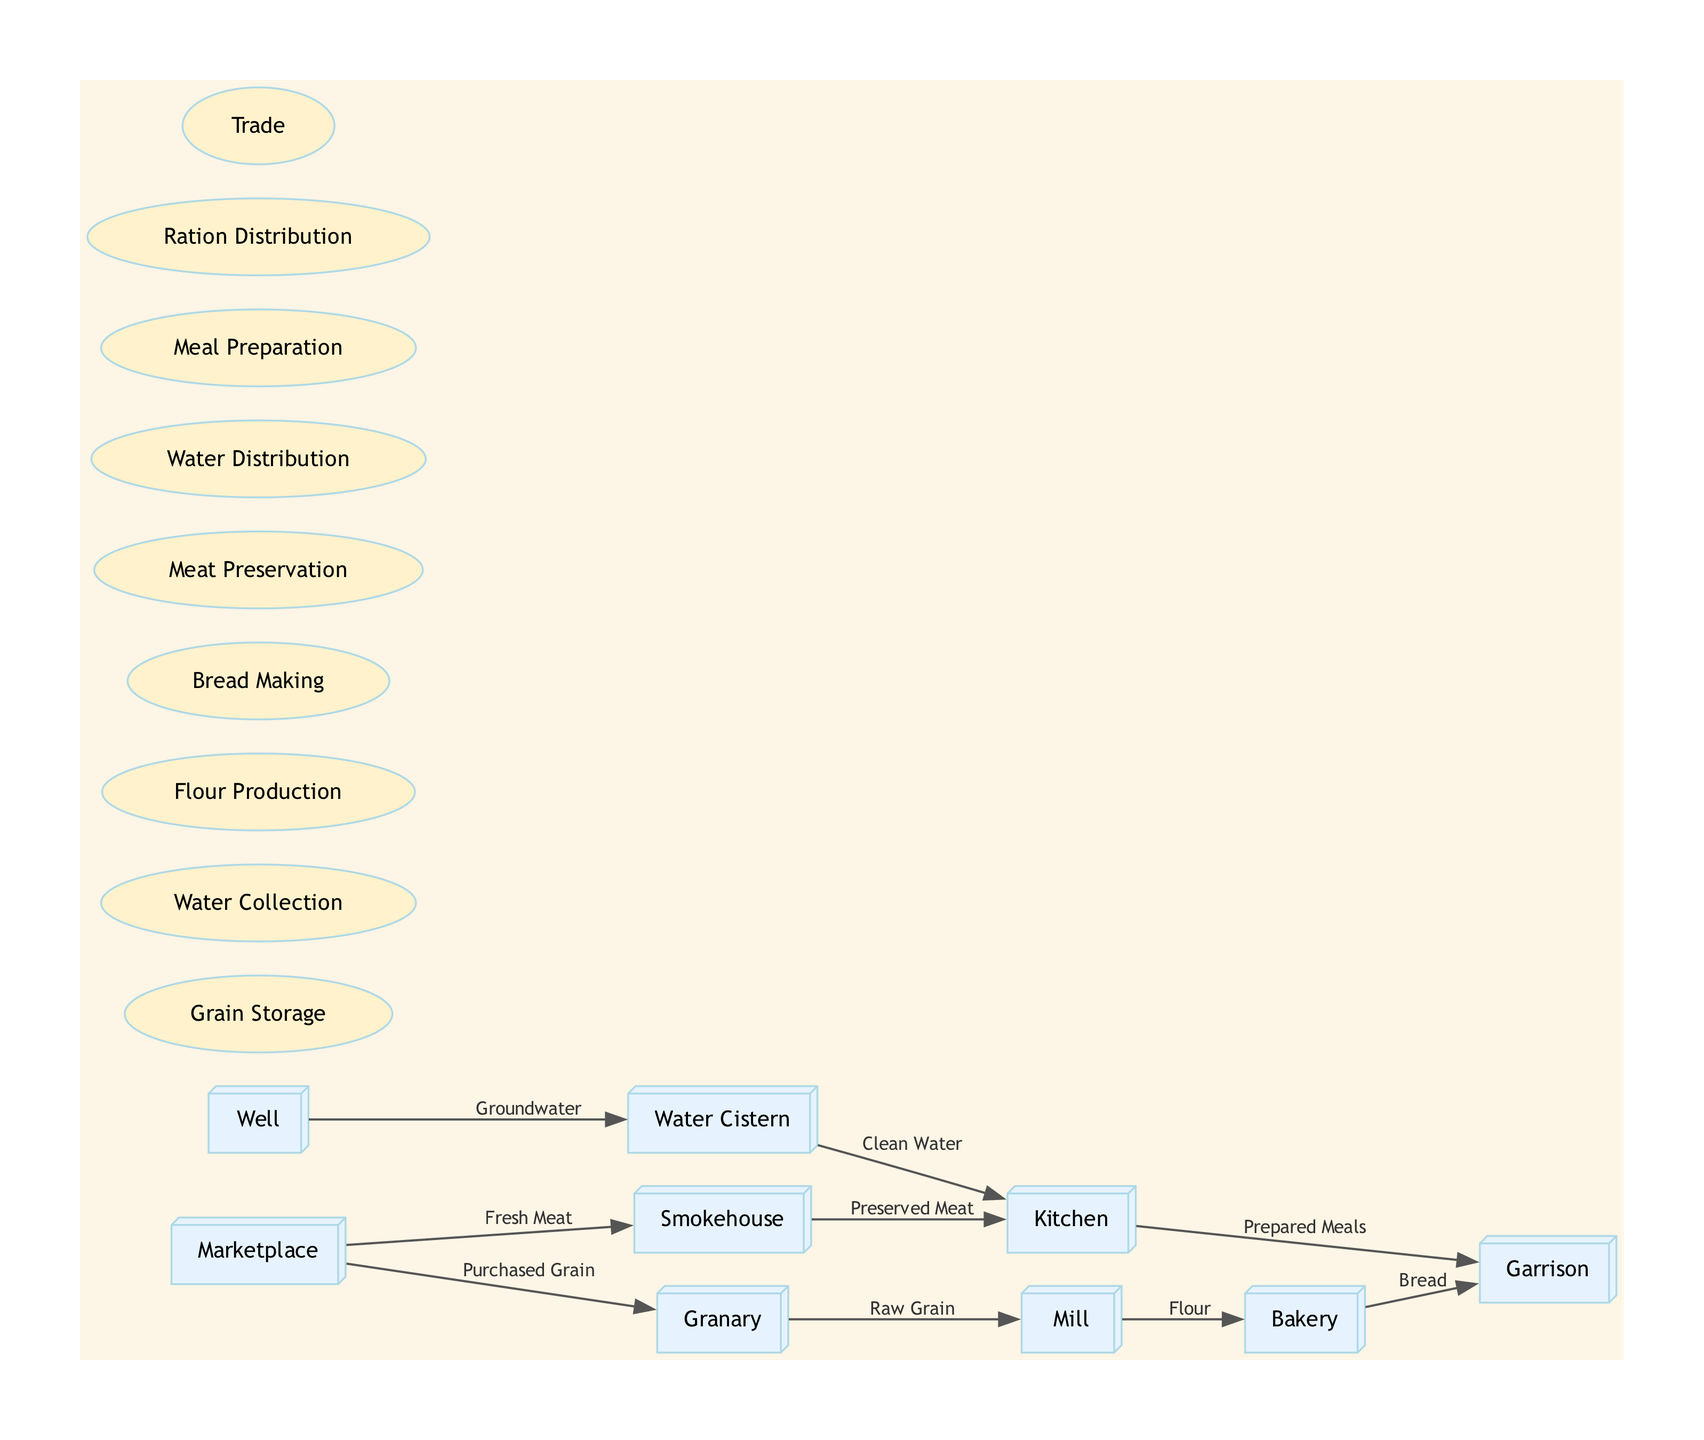What entities are involved in food storage? The entities involved in food storage are the Granary and the Smokehouse. The Granary stores raw grain, while the Smokehouse stores preserved meat.
Answer: Granary, Smokehouse How many processes are illustrated in the diagram? The diagram lists nine processes, including Grain Storage, Water Collection, Flour Production, Bread Making, Meat Preservation, Water Distribution, Meal Preparation, Ration Distribution, and Trade.
Answer: Nine What type of water source is shown connected to the Water Cistern? The Well is shown as the source providing groundwater to the Water Cistern.
Answer: Groundwater Which process sends flour to the Bakery? The Mill is the process that sends flour to the Bakery, receiving input from the Granary.
Answer: Mill What is the final output of the food supply chain to the Garrison? The final outputs of the food supply chain to the Garrison are Bread and Prepared Meals. Bread comes from the Bakery, while Prepared Meals come from the Kitchen.
Answer: Bread, Prepared Meals How many direct data flows lead to the Garrison? There are two direct data flows leading to the Garrison: one from the Bakery (Bread) and another from the Kitchen (Prepared Meals).
Answer: Two From which entity do fresh meat supplies come into the diagram? Fresh meat supplies come into the diagram from the Marketplace, which provides fresh meat to the Smokehouse.
Answer: Marketplace What process is responsible for meat preservation in the settlement? The process responsible for meat preservation is Meat Preservation, which is conducted in the Smokehouse.
Answer: Meat Preservation Which entity collects clean water before it is distributed? The Water Cistern collects clean water before it is distributed to the Kitchen for meal preparation.
Answer: Water Cistern 